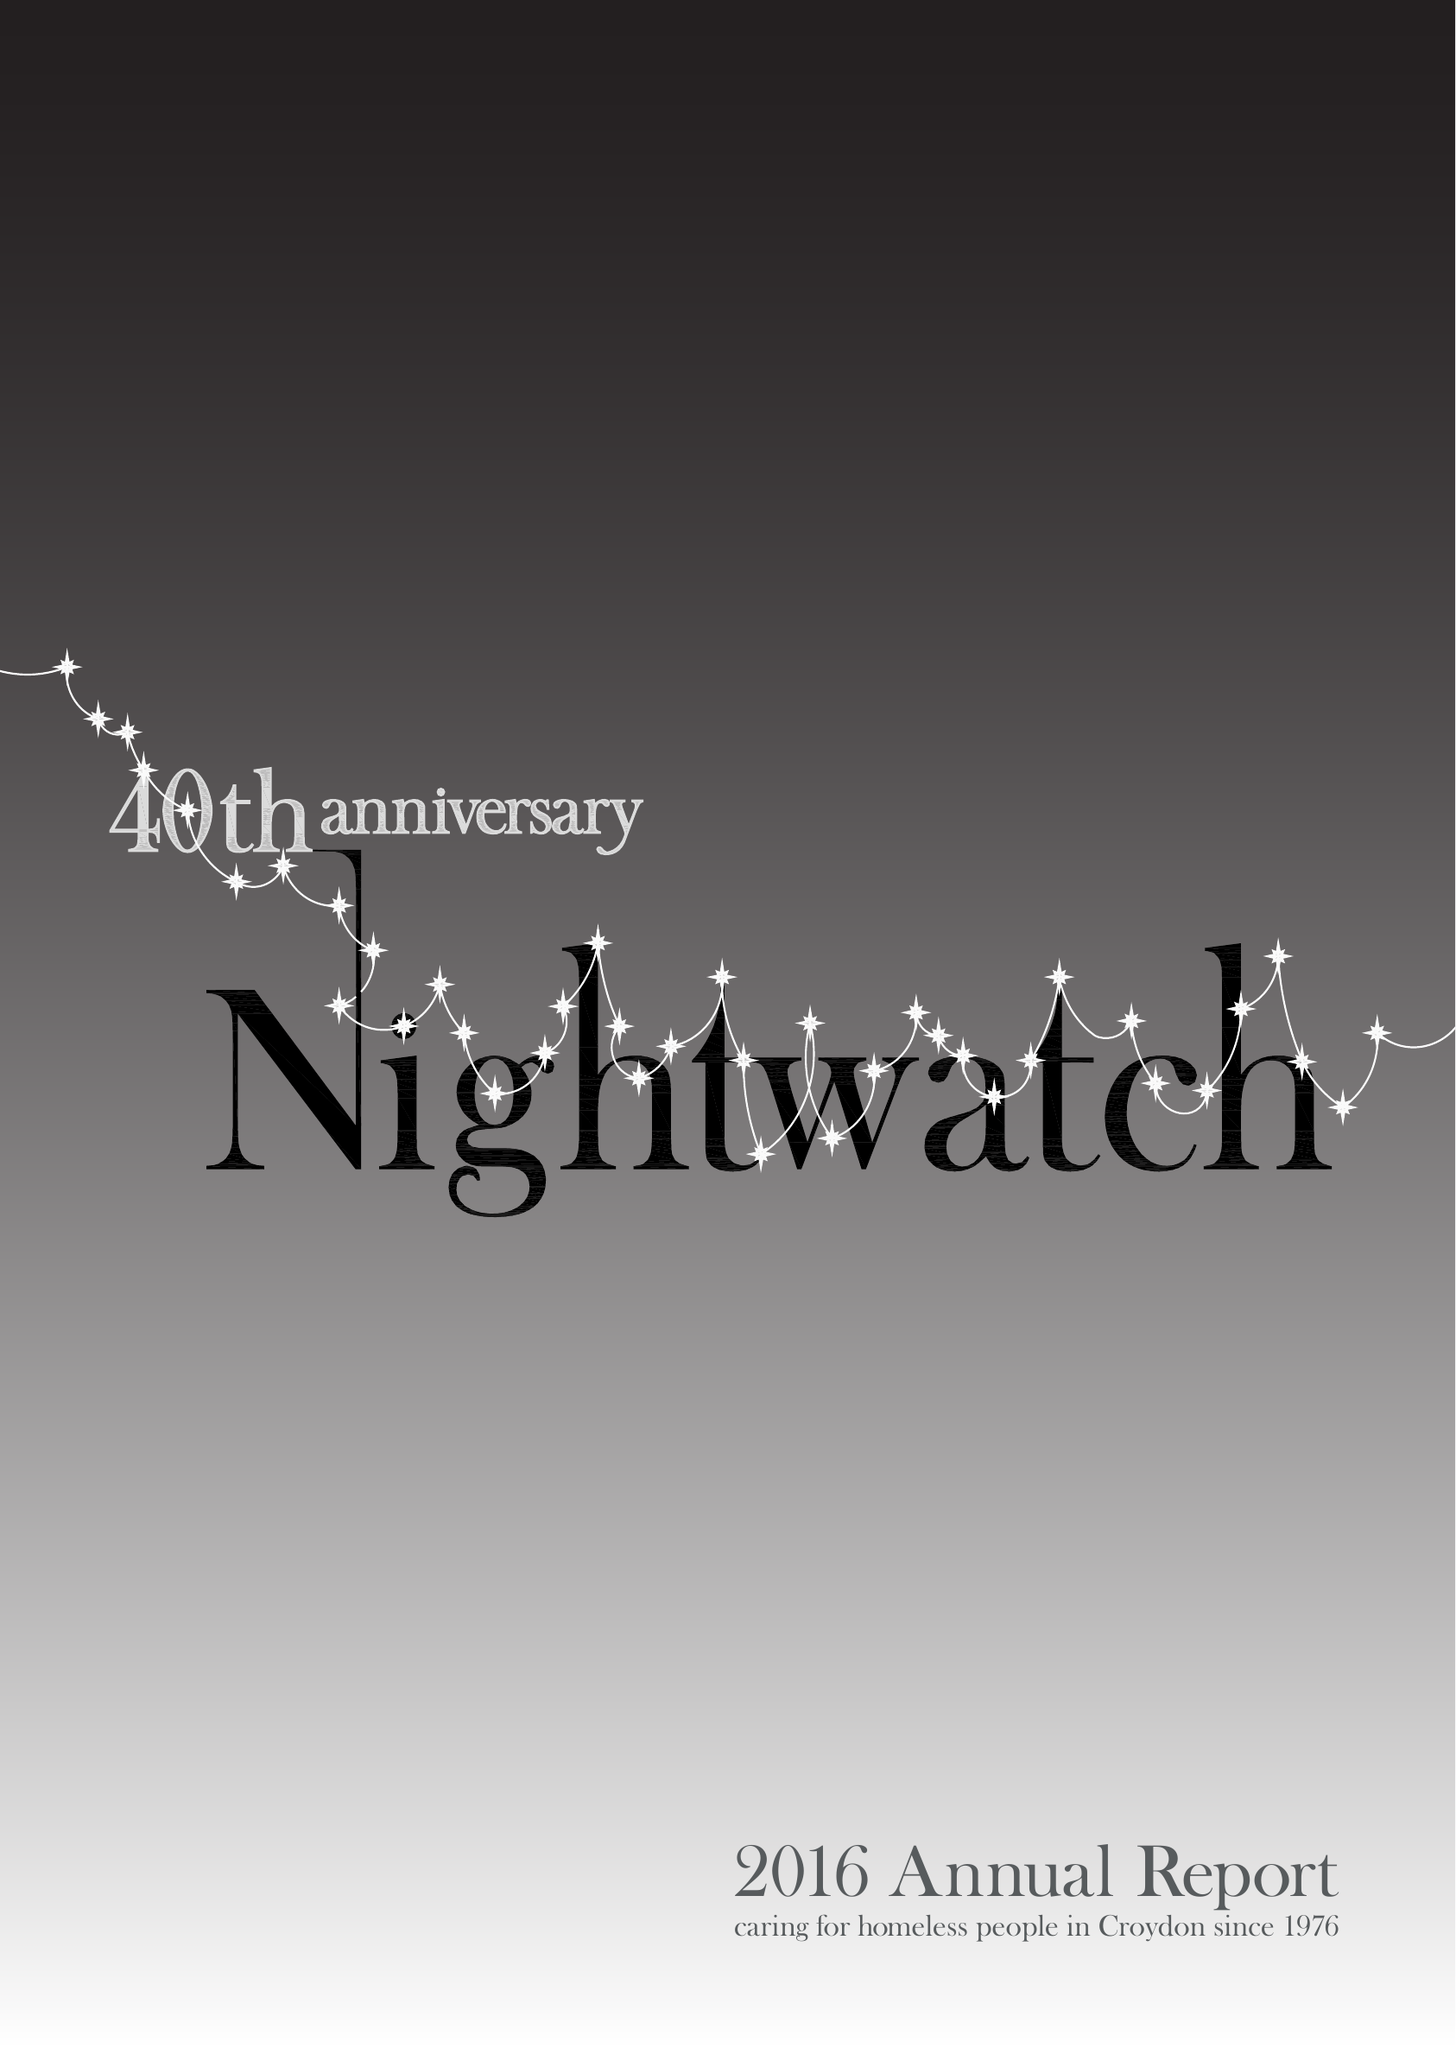What is the value for the address__postcode?
Answer the question using a single word or phrase. SE23 3ZH 